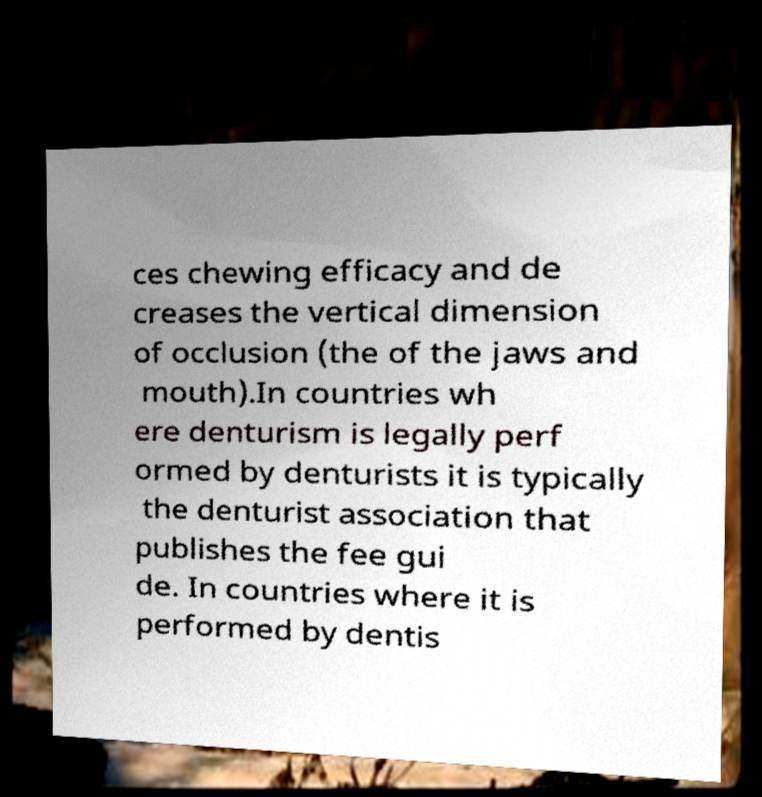I need the written content from this picture converted into text. Can you do that? ces chewing efficacy and de creases the vertical dimension of occlusion (the of the jaws and mouth).In countries wh ere denturism is legally perf ormed by denturists it is typically the denturist association that publishes the fee gui de. In countries where it is performed by dentis 